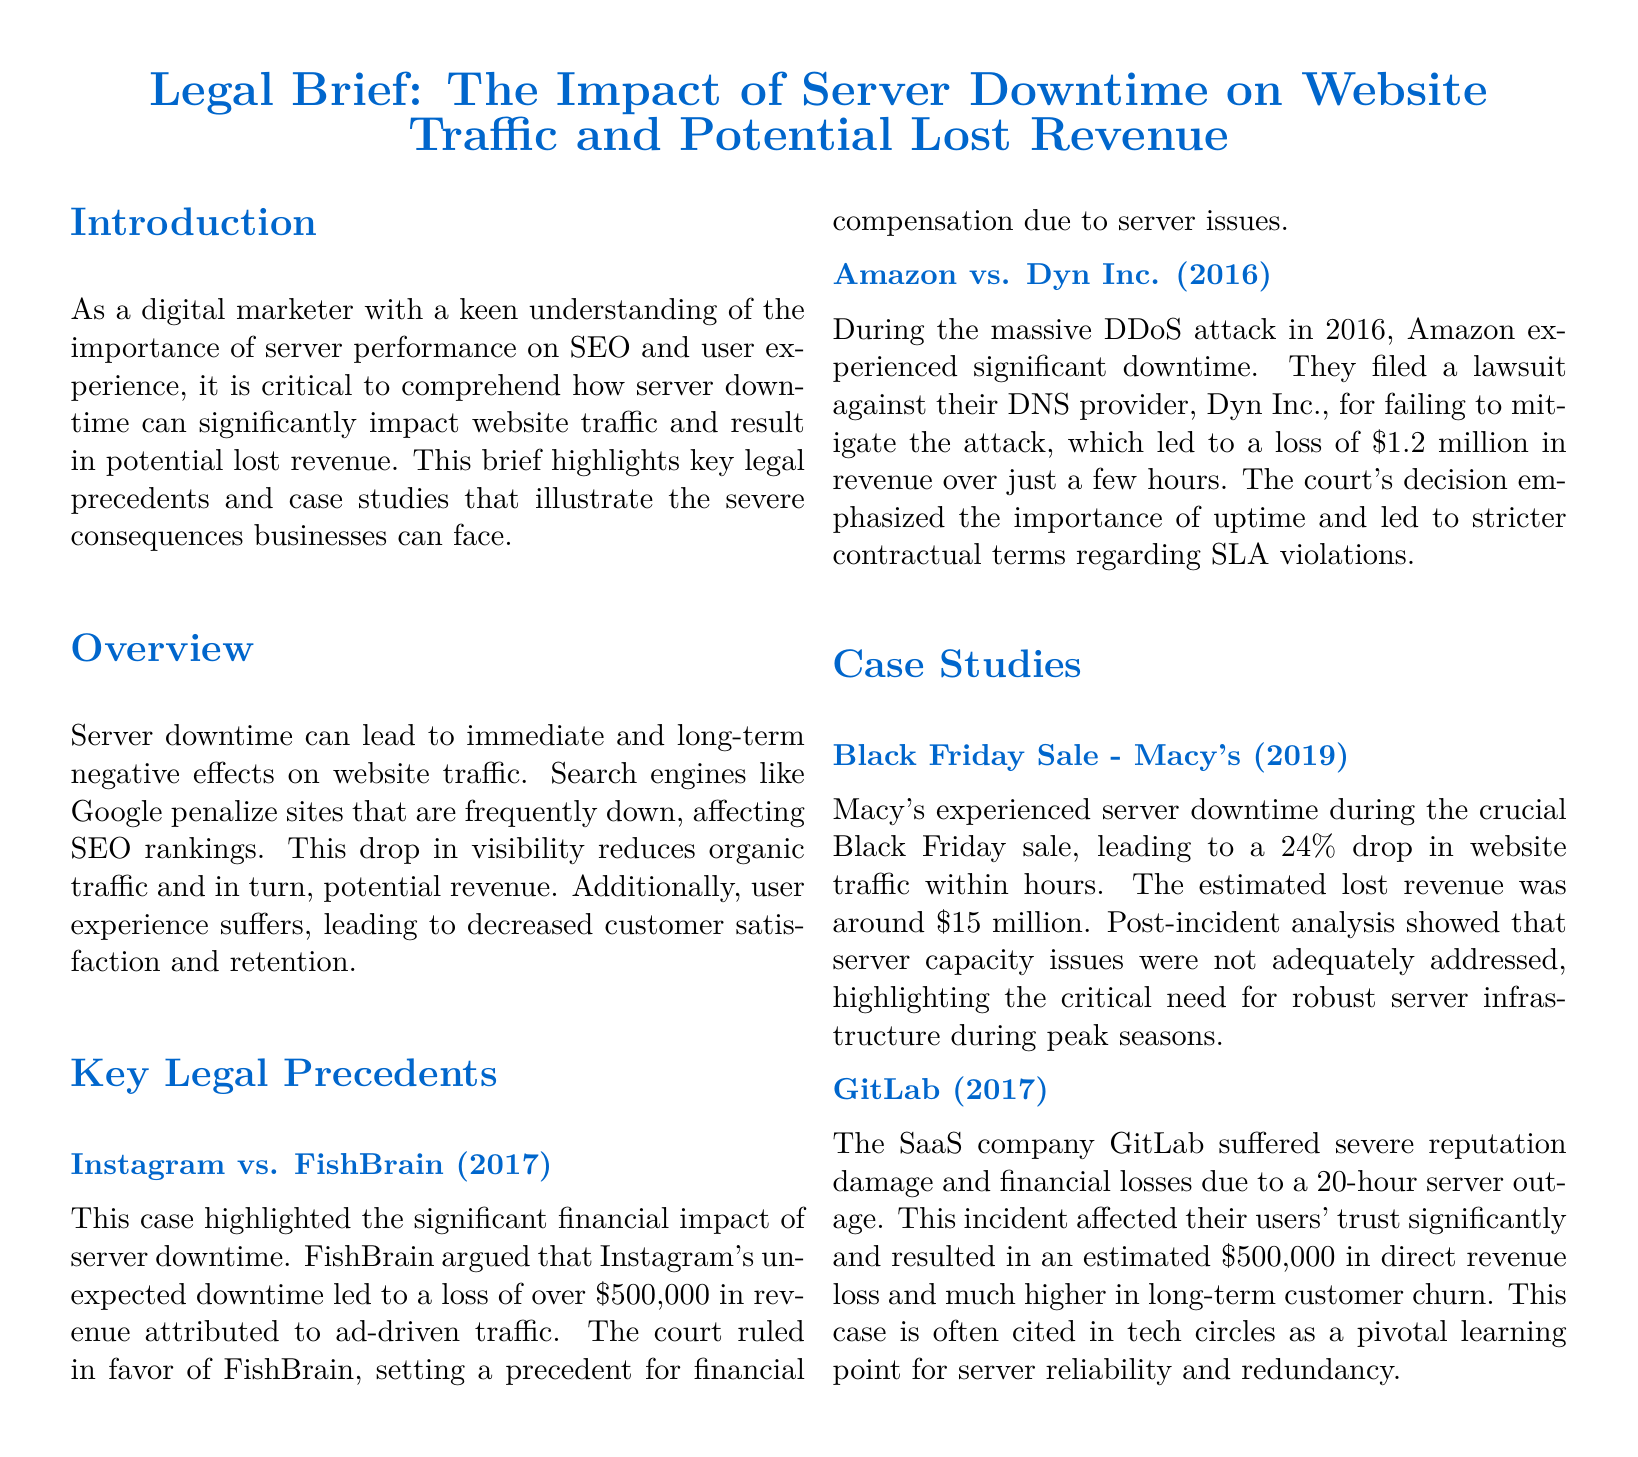What was the revenue loss claimed by FishBrain in the Instagram case? FishBrain claimed a loss of over $500,000 due to Instagram's downtime according to the case details provided.
Answer: $500,000 What major event caused Amazon to experience significant downtime in 2016? The document states that during a massive DDoS attack in 2016, Amazon's downtime occurred.
Answer: DDoS attack How much revenue did Macy's lose during the Black Friday sale due to server downtime? The document indicates that Macy's experienced an estimated lost revenue of around $15 million during the incident.
Answer: $15 million What is the estimated direct revenue loss for GitLab from their server outage? According to the case study mentioned, GitLab's estimated direct revenue loss was around $500,000 due to the server outage.
Answer: $500,000 Which case indicated the need for stricter contractual terms regarding SLA violations? The Amazon vs. Dyn Inc. case emphasized the importance of uptime and led to stricter contractual terms regarding SLA violations.
Answer: Amazon vs. Dyn Inc What percentage drop in website traffic did Macy's experience during downtime? The document states Macy's experienced a 24% drop in website traffic during their downtime.
Answer: 24% What year did the server outage incident occur for GitLab? As per the document, the GitLab incident took place in 2017.
Answer: 2017 What type of document is this legal brief categorized as? The document is categorized as a legal brief addressing server downtime impacts on businesses.
Answer: Legal brief 